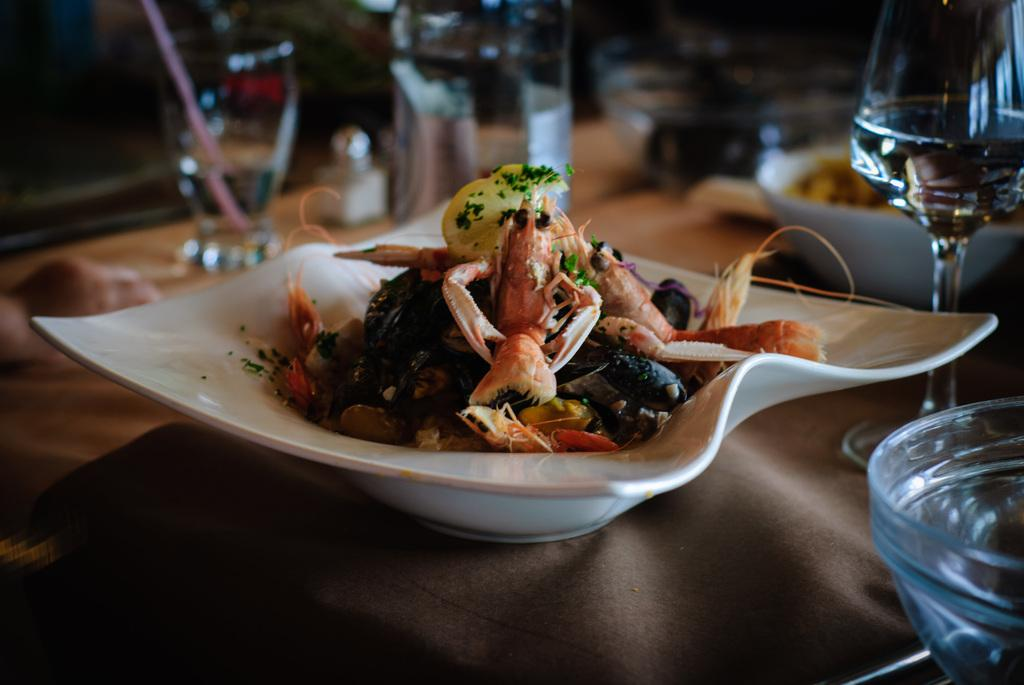What is on the plate in the foreground of the image? There are food items on a plate in the foreground of the image. Where is the plate located? The plate is on a table. What can be seen in the background of the image? There are glasses and other objects in the background of the image. Is there a cobweb hanging from the ceiling in the image? There is no mention of a cobweb in the provided facts, so we cannot determine if one is present in the image. 